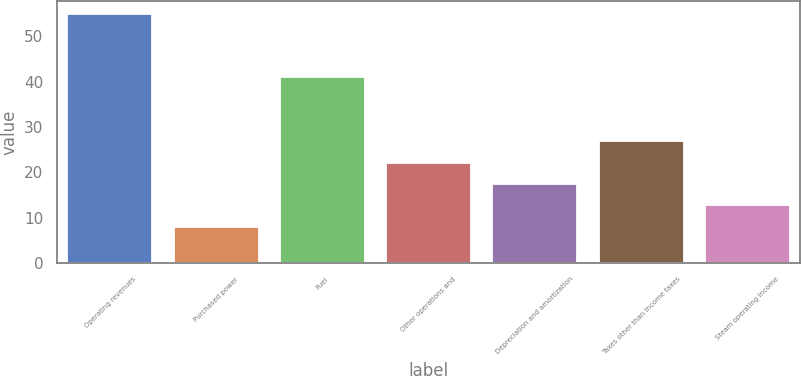<chart> <loc_0><loc_0><loc_500><loc_500><bar_chart><fcel>Operating revenues<fcel>Purchased power<fcel>Fuel<fcel>Other operations and<fcel>Depreciation and amortization<fcel>Taxes other than income taxes<fcel>Steam operating income<nl><fcel>55<fcel>8<fcel>41<fcel>22.1<fcel>17.4<fcel>26.8<fcel>12.7<nl></chart> 